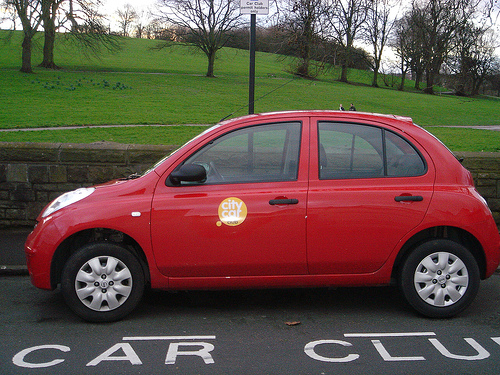<image>
Is the car next to the road? No. The car is not positioned next to the road. They are located in different areas of the scene. Is the car on the road? Yes. Looking at the image, I can see the car is positioned on top of the road, with the road providing support. Is the sticker on the car window? No. The sticker is not positioned on the car window. They may be near each other, but the sticker is not supported by or resting on top of the car window. 